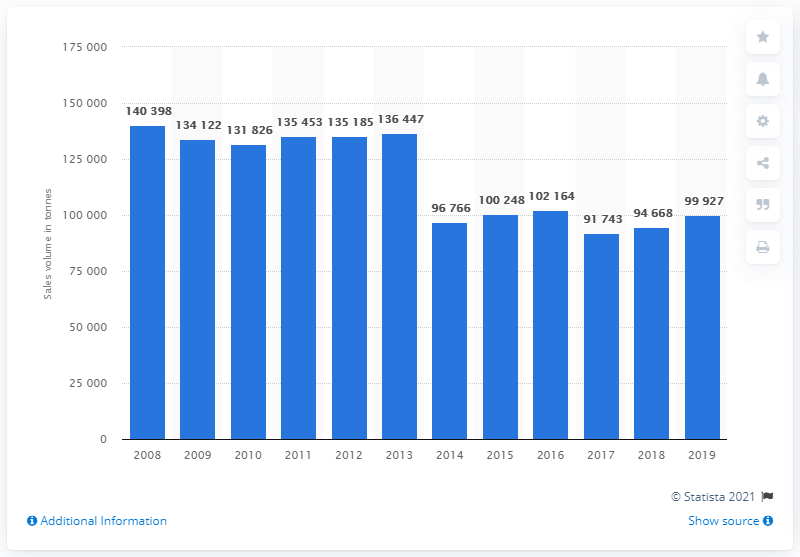Identify some key points in this picture. The sales volume of tea in the UK in 2019 was approximately 999,270 units. 